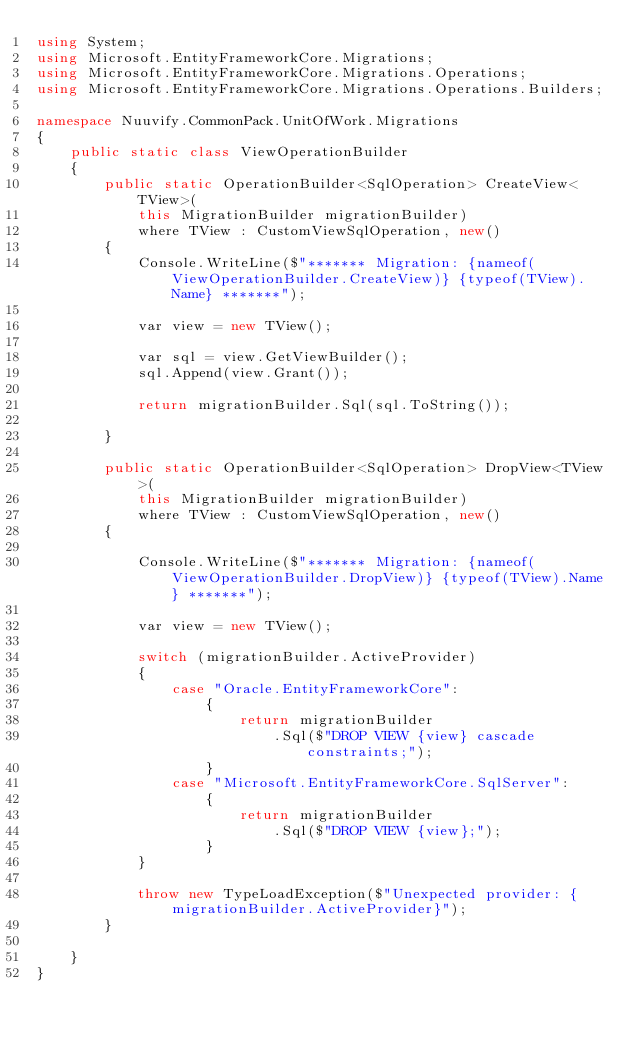<code> <loc_0><loc_0><loc_500><loc_500><_C#_>using System;
using Microsoft.EntityFrameworkCore.Migrations;
using Microsoft.EntityFrameworkCore.Migrations.Operations;
using Microsoft.EntityFrameworkCore.Migrations.Operations.Builders;

namespace Nuuvify.CommonPack.UnitOfWork.Migrations
{
    public static class ViewOperationBuilder
    {
        public static OperationBuilder<SqlOperation> CreateView<TView>(
            this MigrationBuilder migrationBuilder)
            where TView : CustomViewSqlOperation, new()
        {
            Console.WriteLine($"******* Migration: {nameof(ViewOperationBuilder.CreateView)} {typeof(TView).Name} *******");

            var view = new TView();

            var sql = view.GetViewBuilder();
            sql.Append(view.Grant());

            return migrationBuilder.Sql(sql.ToString());

        }

        public static OperationBuilder<SqlOperation> DropView<TView>(
            this MigrationBuilder migrationBuilder) 
            where TView : CustomViewSqlOperation, new()
        {

            Console.WriteLine($"******* Migration: {nameof(ViewOperationBuilder.DropView)} {typeof(TView).Name} *******");

            var view = new TView();

            switch (migrationBuilder.ActiveProvider)
            {
                case "Oracle.EntityFrameworkCore":
                    {
                        return migrationBuilder
                            .Sql($"DROP VIEW {view} cascade constraints;");
                    }
                case "Microsoft.EntityFrameworkCore.SqlServer":
                    {
                        return migrationBuilder
                            .Sql($"DROP VIEW {view};");
                    }
            }

            throw new TypeLoadException($"Unexpected provider: {migrationBuilder.ActiveProvider}");
        }

    }
}</code> 